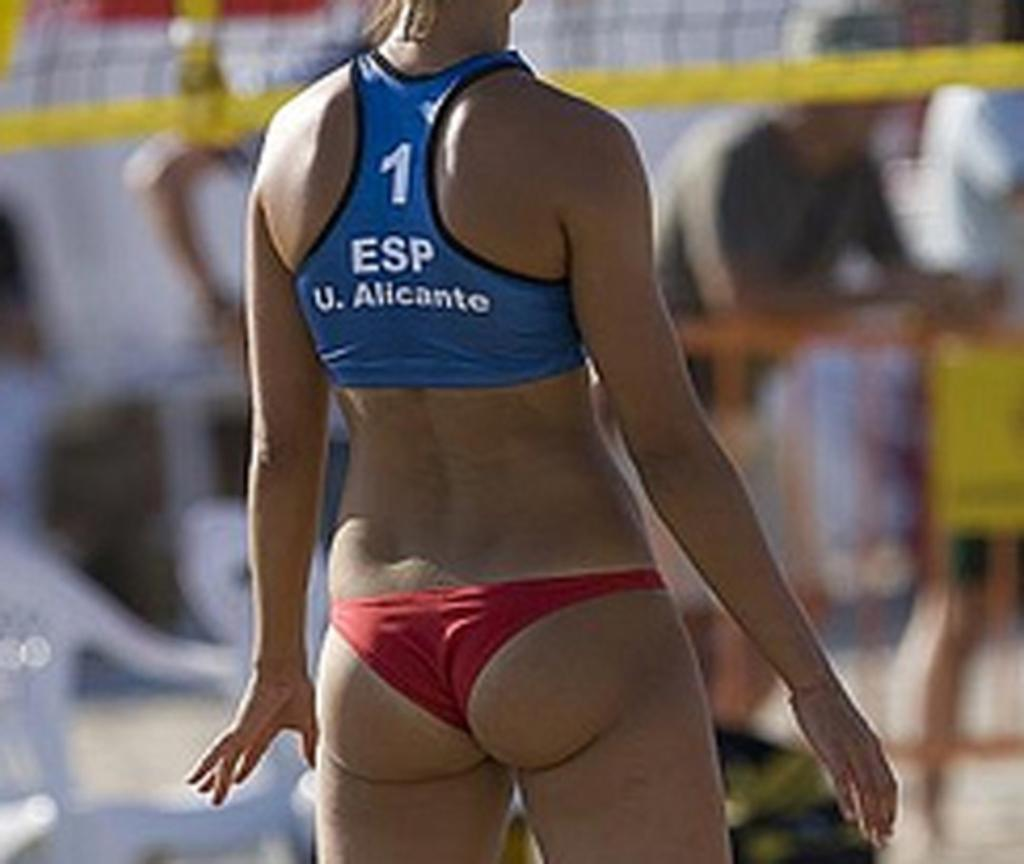Provide a one-sentence caption for the provided image. A woman wearing a bikini and it has the digit 1 on the back. 